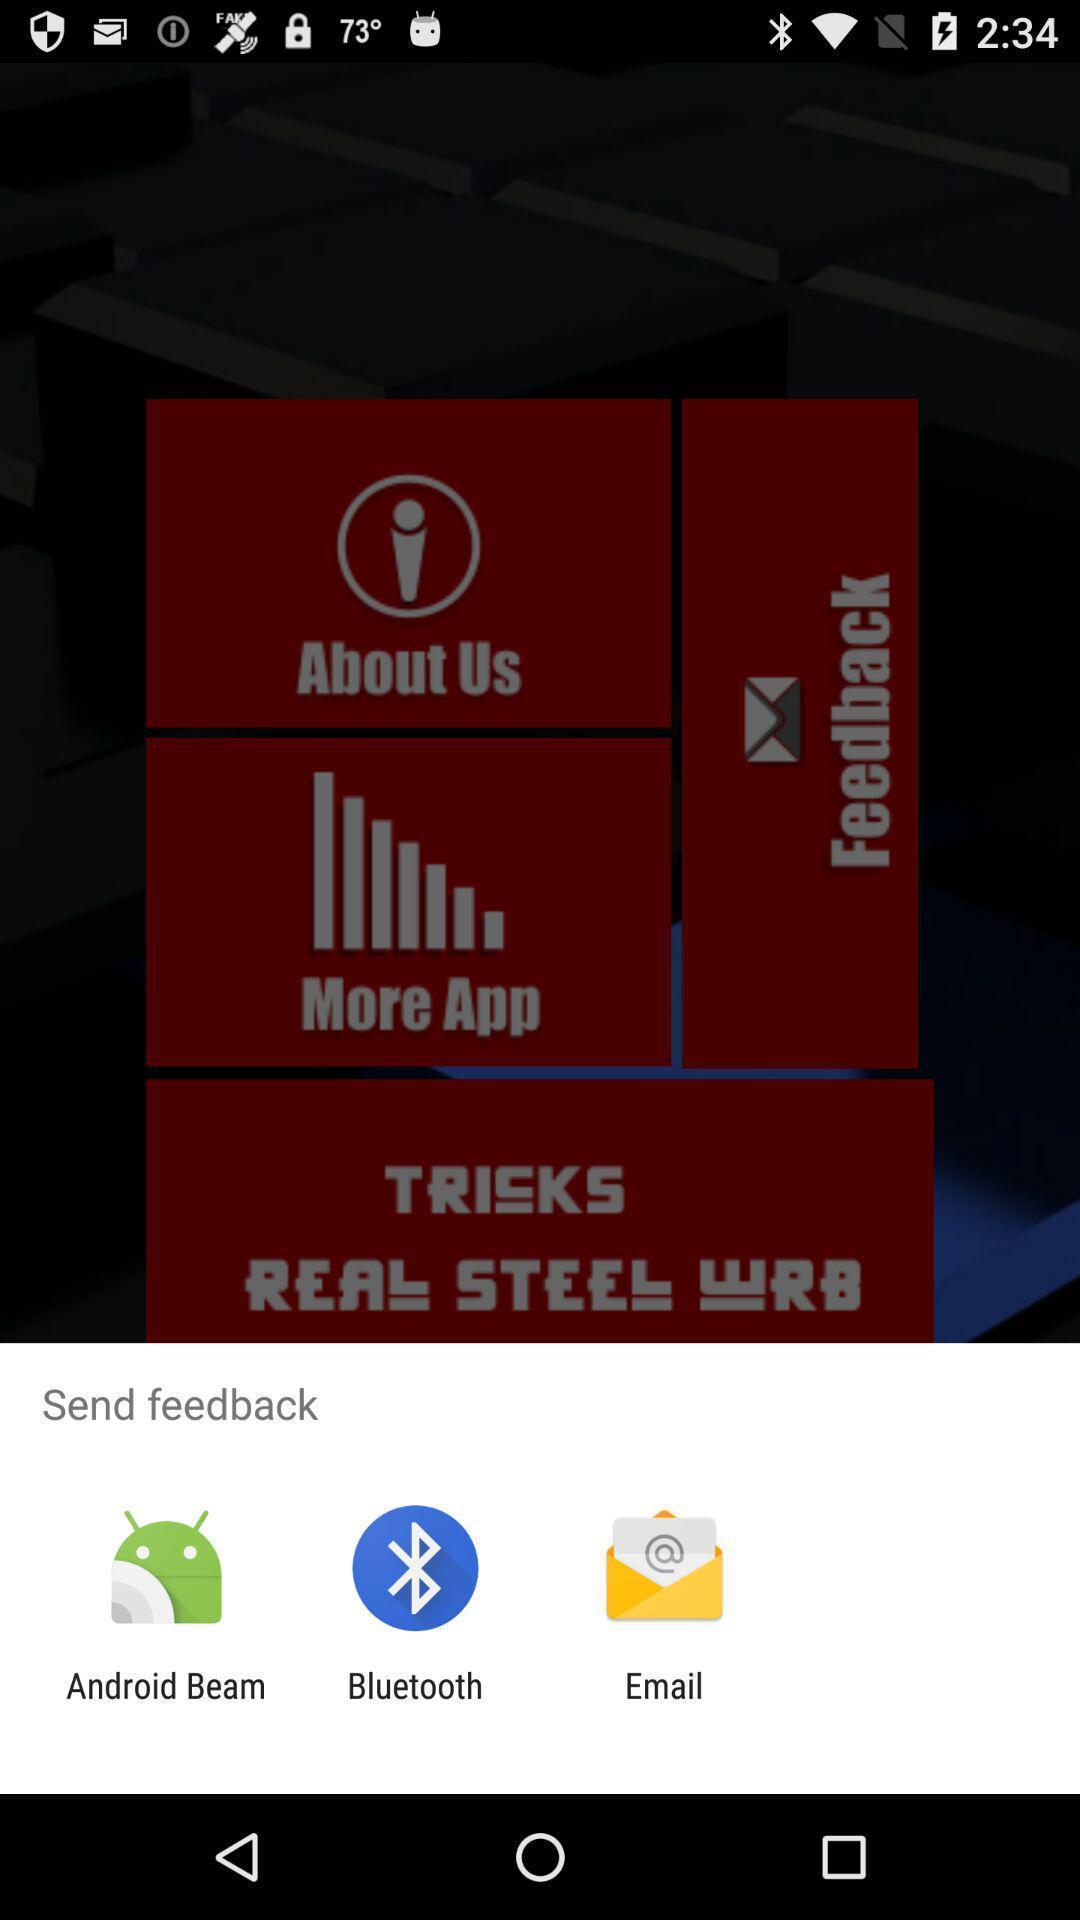What is the overall content of this screenshot? Pop-up to send feedback via different apps. 